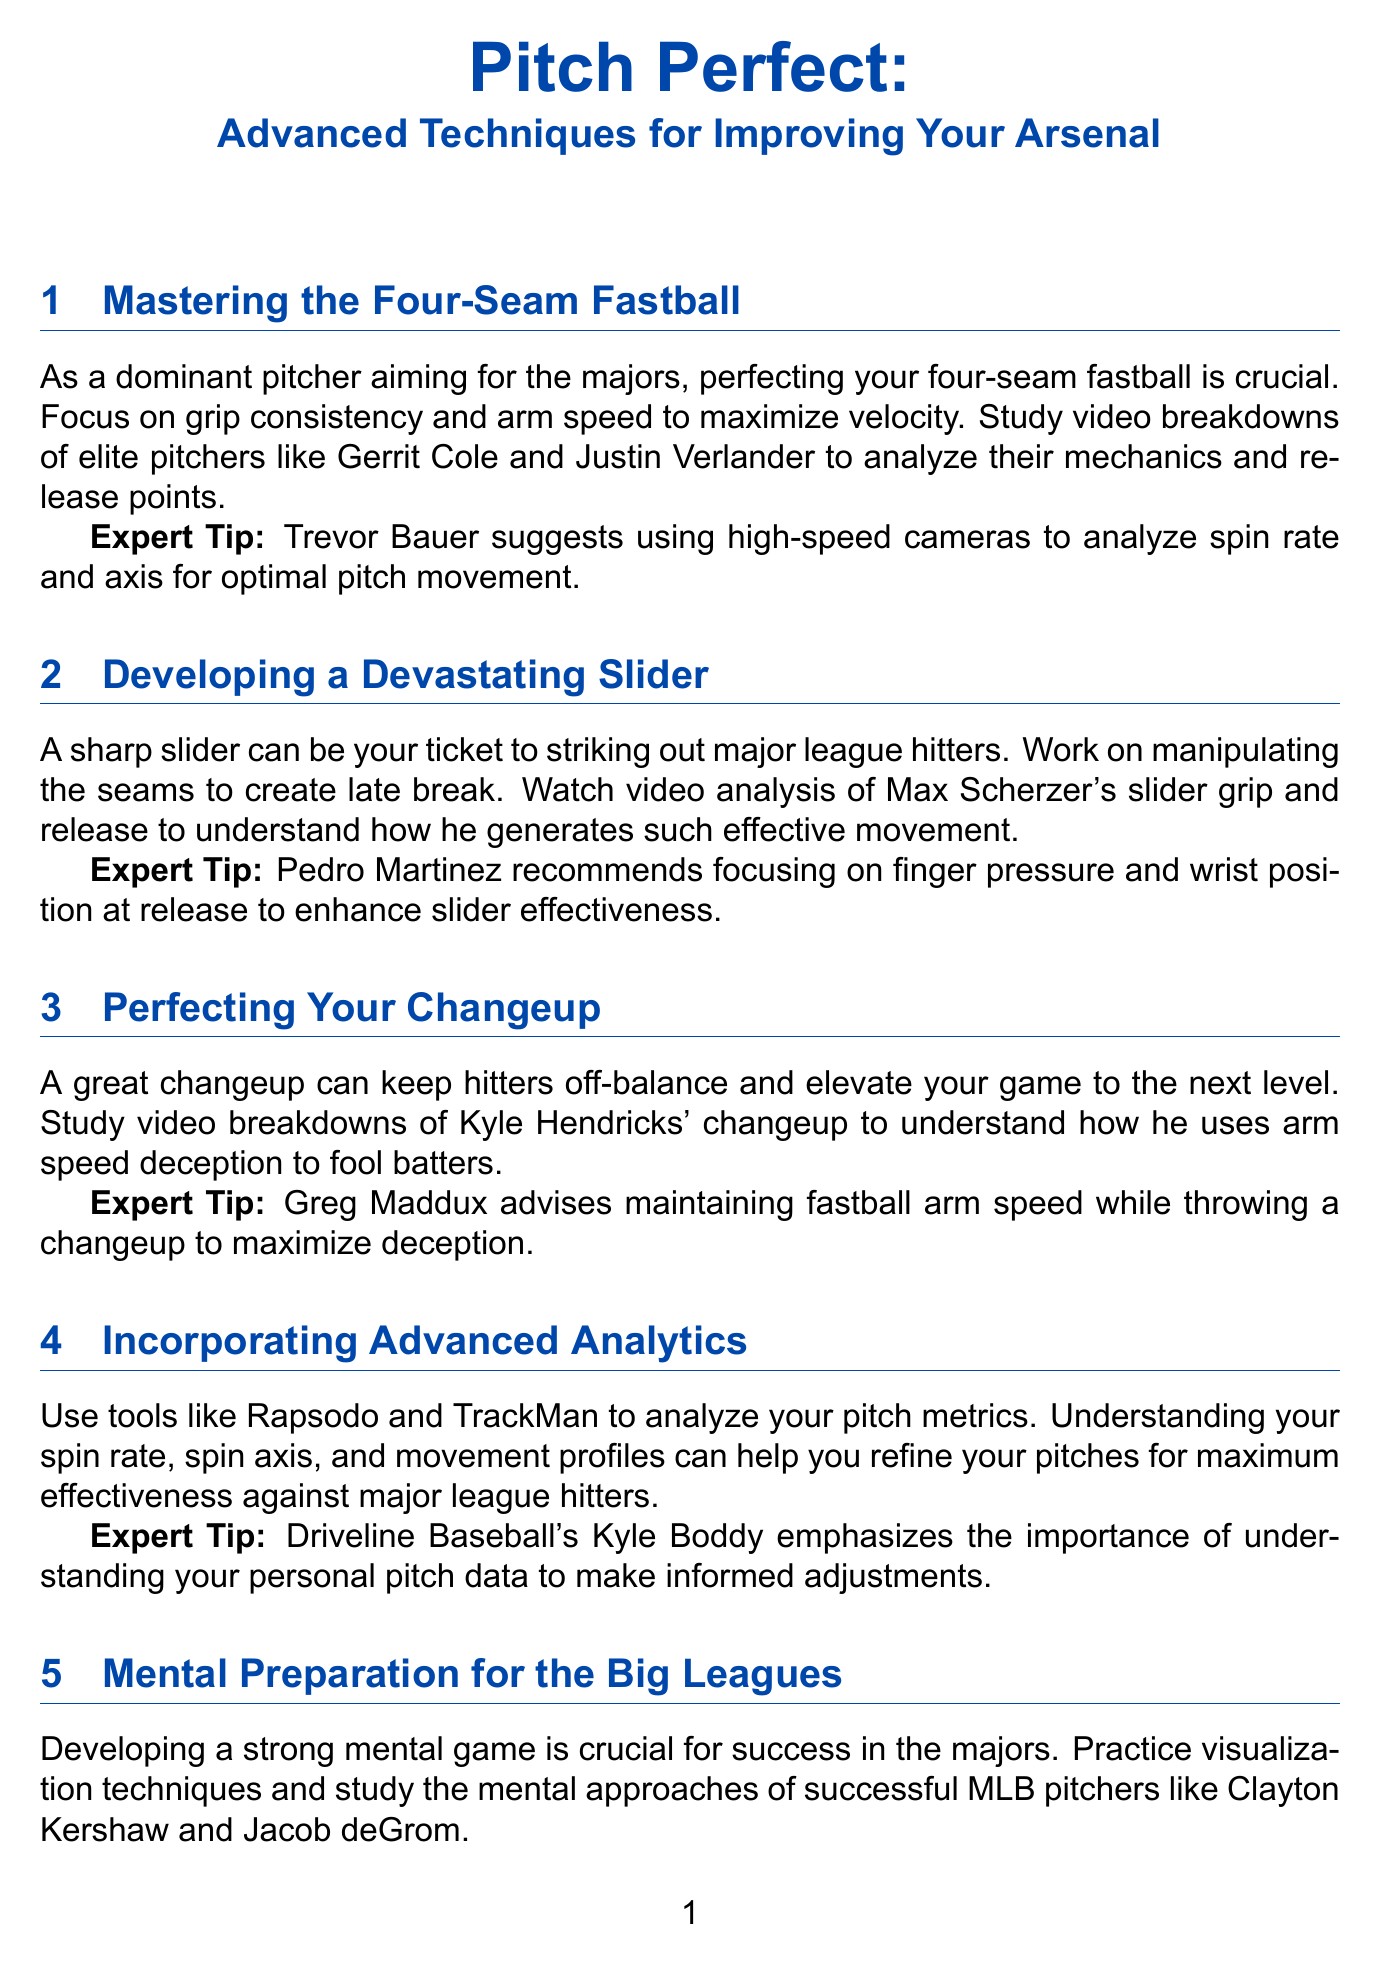What is the focus for perfecting the four-seam fastball? The document states that the focus should be on grip consistency and arm speed to maximize velocity.
Answer: grip consistency and arm speed Who suggests using high-speed cameras for analyzing pitch movement? The expert tip section indicates that Trevor Bauer suggests using high-speed cameras for analysis.
Answer: Trevor Bauer What is essential for developing a devastating slider? The content specifies that manipulating the seams to create late break is essential.
Answer: manipulating the seams What can keep hitters off-balance according to the newsletter? The document mentions that a great changeup can keep hitters off-balance and elevate your game.
Answer: a great changeup Which analytics tools are recommended in the newsletter? The document lists tools like Rapsodo and TrackMan as recommended for analyzing pitch metrics.
Answer: Rapsodo and TrackMan What is the recommended mental prep approach before pitching? The newsletter advises that a consistent pre-pitch routine is crucial for maintaining focus.
Answer: a consistent pre-pitch routine Which expert emphasizes the understanding of personal pitch data? According to the expert tip, Kyle Boddy from Driveline Baseball emphasizes this understanding.
Answer: Kyle Boddy What is the key to injury prevention as per the document? The content states that implementing a comprehensive arm care routine is key to minimizing injury risk.
Answer: a comprehensive arm care routine 